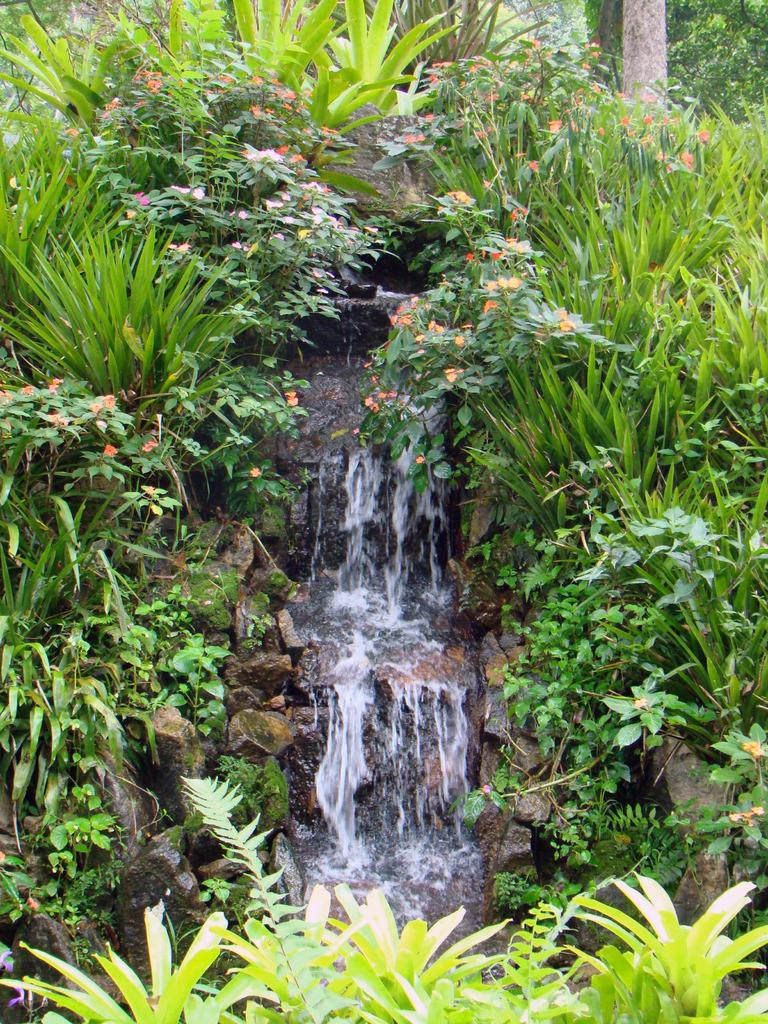What types of living organisms are in the image? The image contains plants and flowers. What natural feature can be seen in the image? There is a small waterfall in the image. What part of a tree is visible in the image? The top of the image appears to be the trunk of a tree. What type of umbrella is being used by the flowers in the image? There is no umbrella present in the image; it features plants, flowers, and a waterfall. 